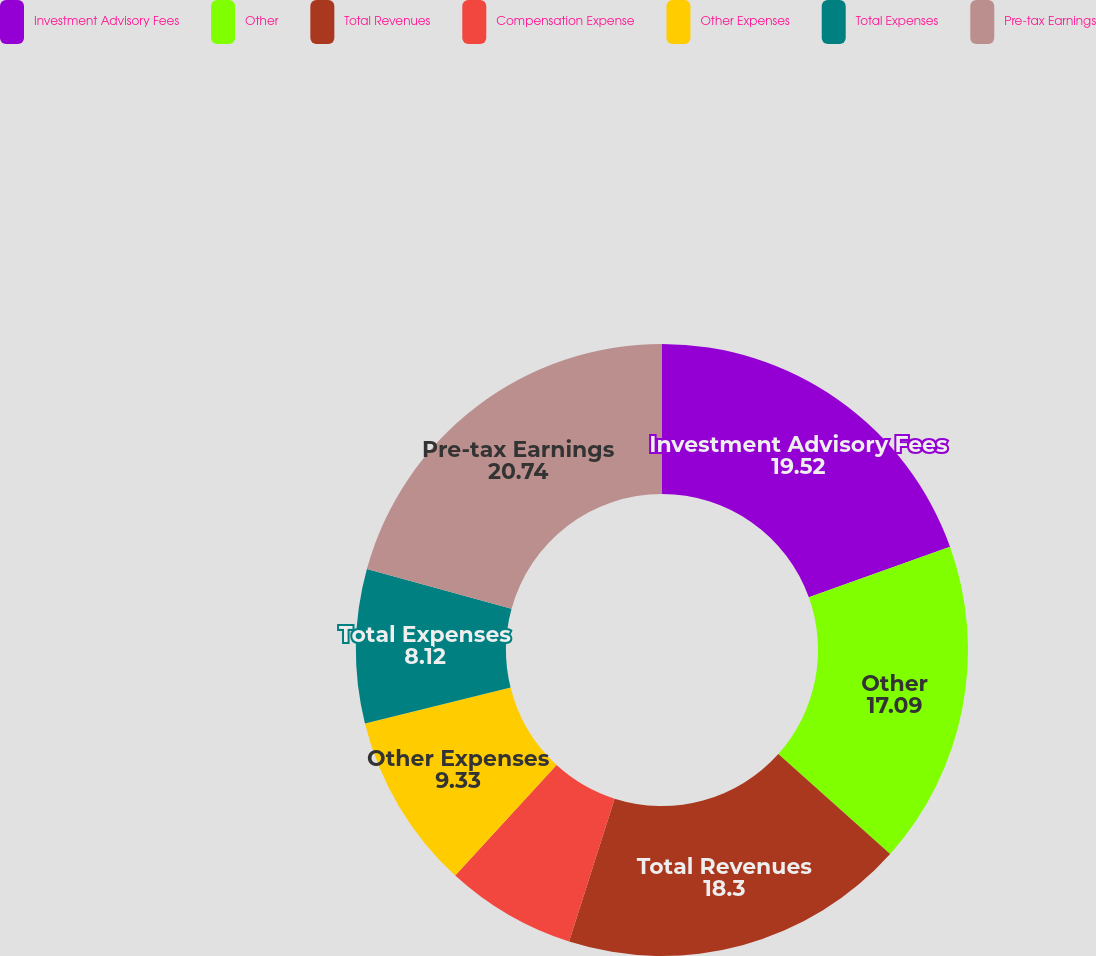Convert chart. <chart><loc_0><loc_0><loc_500><loc_500><pie_chart><fcel>Investment Advisory Fees<fcel>Other<fcel>Total Revenues<fcel>Compensation Expense<fcel>Other Expenses<fcel>Total Expenses<fcel>Pre-tax Earnings<nl><fcel>19.52%<fcel>17.09%<fcel>18.3%<fcel>6.9%<fcel>9.33%<fcel>8.12%<fcel>20.74%<nl></chart> 